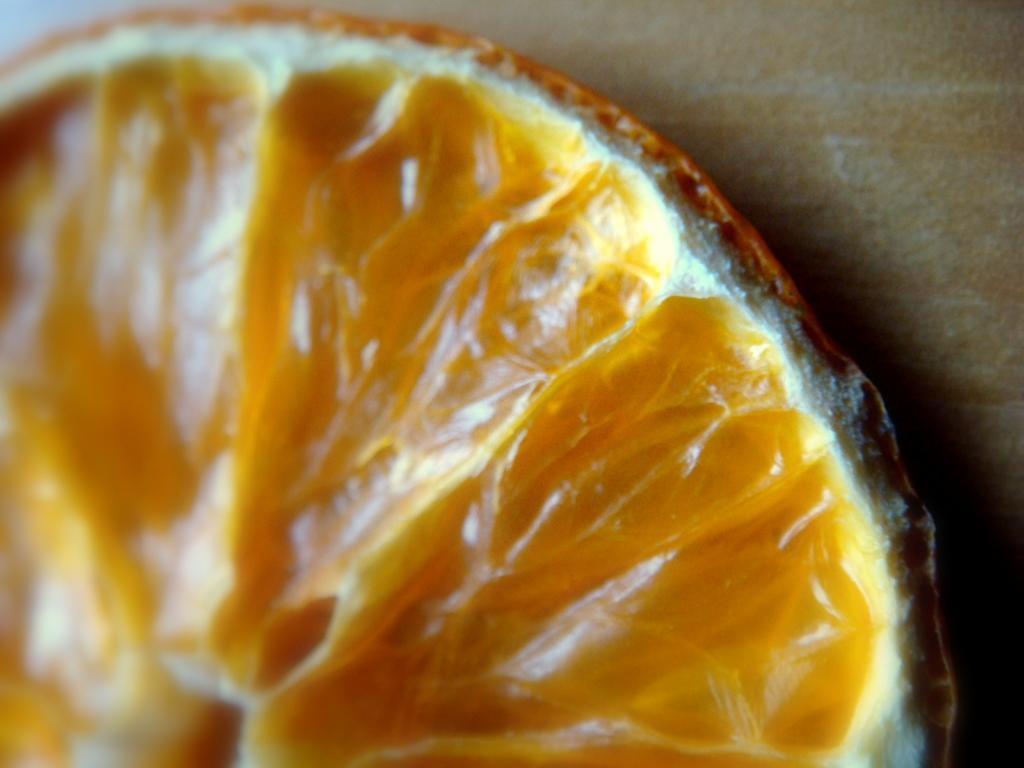Could you give a brief overview of what you see in this image? In the foreground of this image, it seems like an orange slice on the surface. 